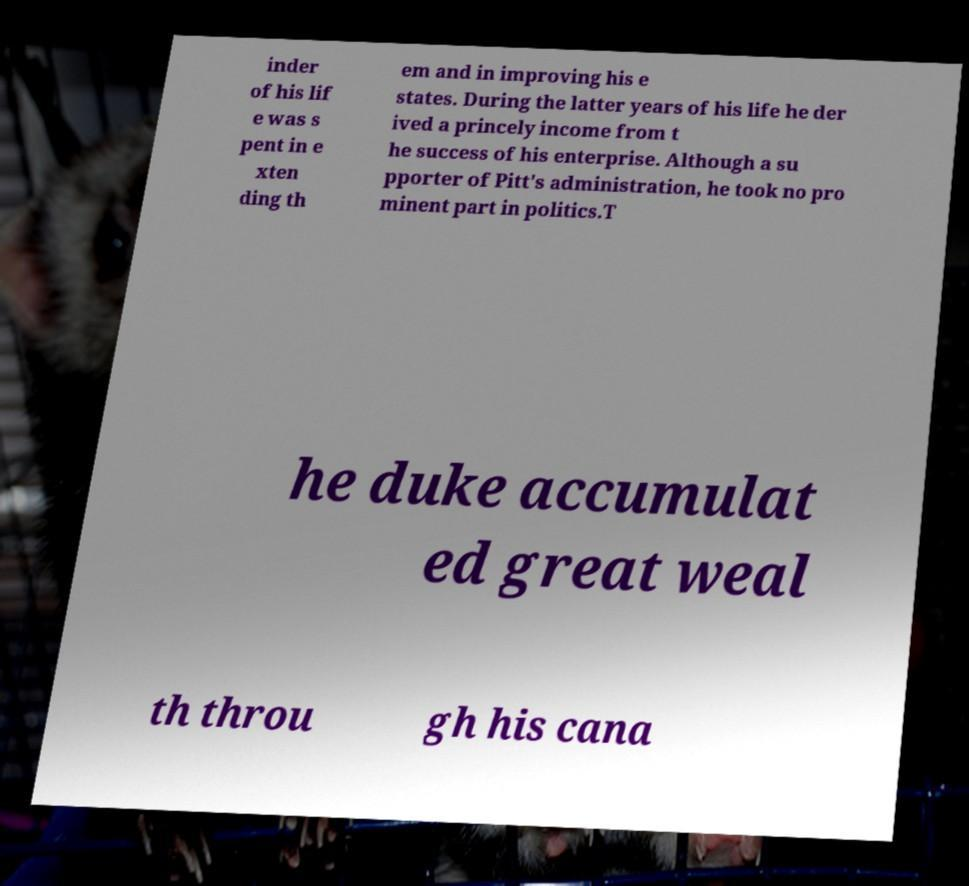What messages or text are displayed in this image? I need them in a readable, typed format. inder of his lif e was s pent in e xten ding th em and in improving his e states. During the latter years of his life he der ived a princely income from t he success of his enterprise. Although a su pporter of Pitt's administration, he took no pro minent part in politics.T he duke accumulat ed great weal th throu gh his cana 